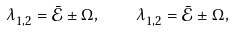Convert formula to latex. <formula><loc_0><loc_0><loc_500><loc_500>\lambda _ { 1 , 2 } ^ { } = \bar { \mathcal { E } } \pm \Omega _ { } , \quad \lambda _ { 1 , 2 } ^ { } = \bar { \mathcal { E } } \pm \Omega _ { } ,</formula> 